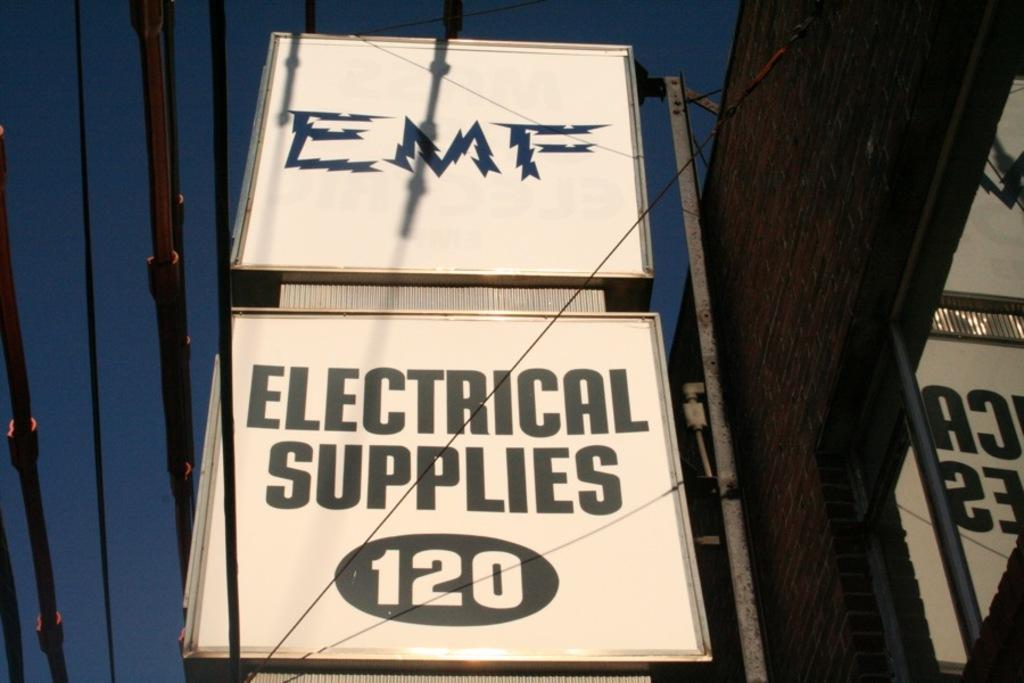<image>
Create a compact narrative representing the image presented. A large store sign for EMF Electrical Supplies 120. 